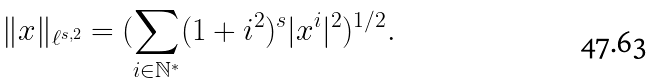Convert formula to latex. <formula><loc_0><loc_0><loc_500><loc_500>\| x \| _ { \ell ^ { s , 2 } } = ( \sum _ { i \in \mathbb { N } ^ { * } } ( 1 + i ^ { 2 } ) ^ { s } | x ^ { i } | ^ { 2 } ) ^ { 1 / 2 } .</formula> 